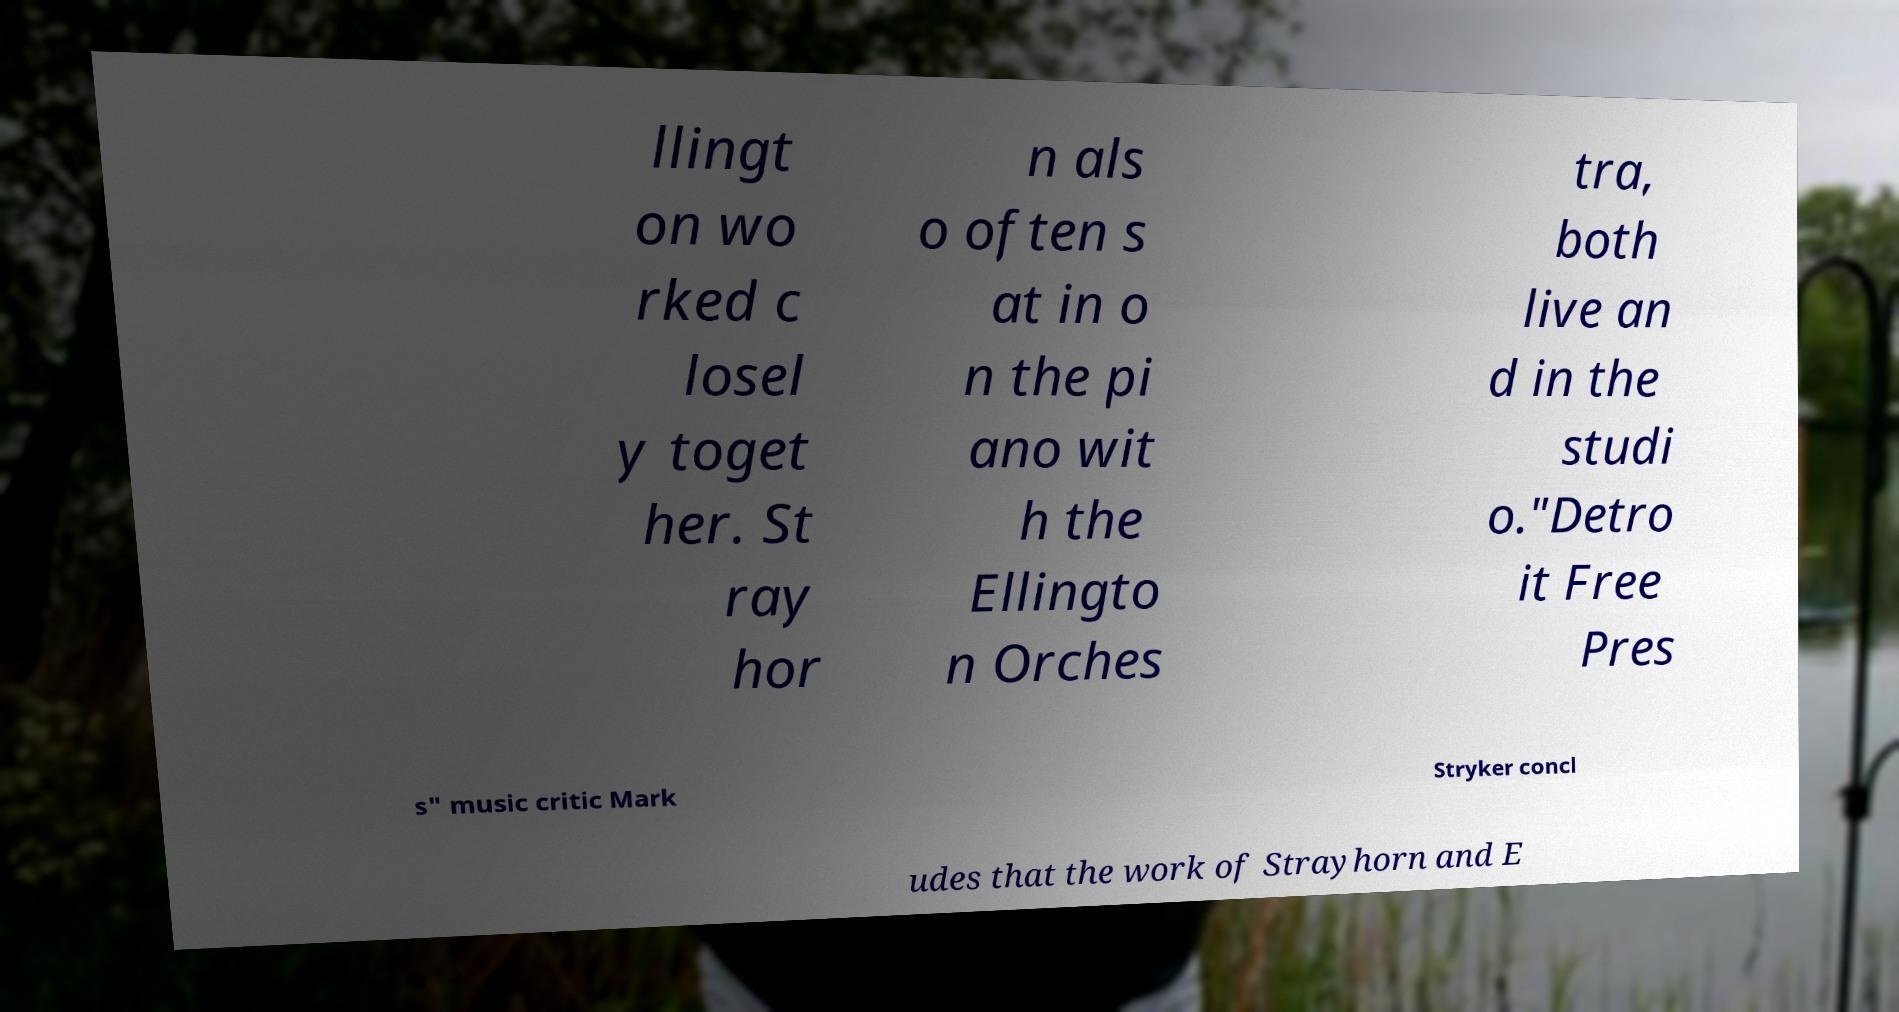What messages or text are displayed in this image? I need them in a readable, typed format. llingt on wo rked c losel y toget her. St ray hor n als o often s at in o n the pi ano wit h the Ellingto n Orches tra, both live an d in the studi o."Detro it Free Pres s" music critic Mark Stryker concl udes that the work of Strayhorn and E 